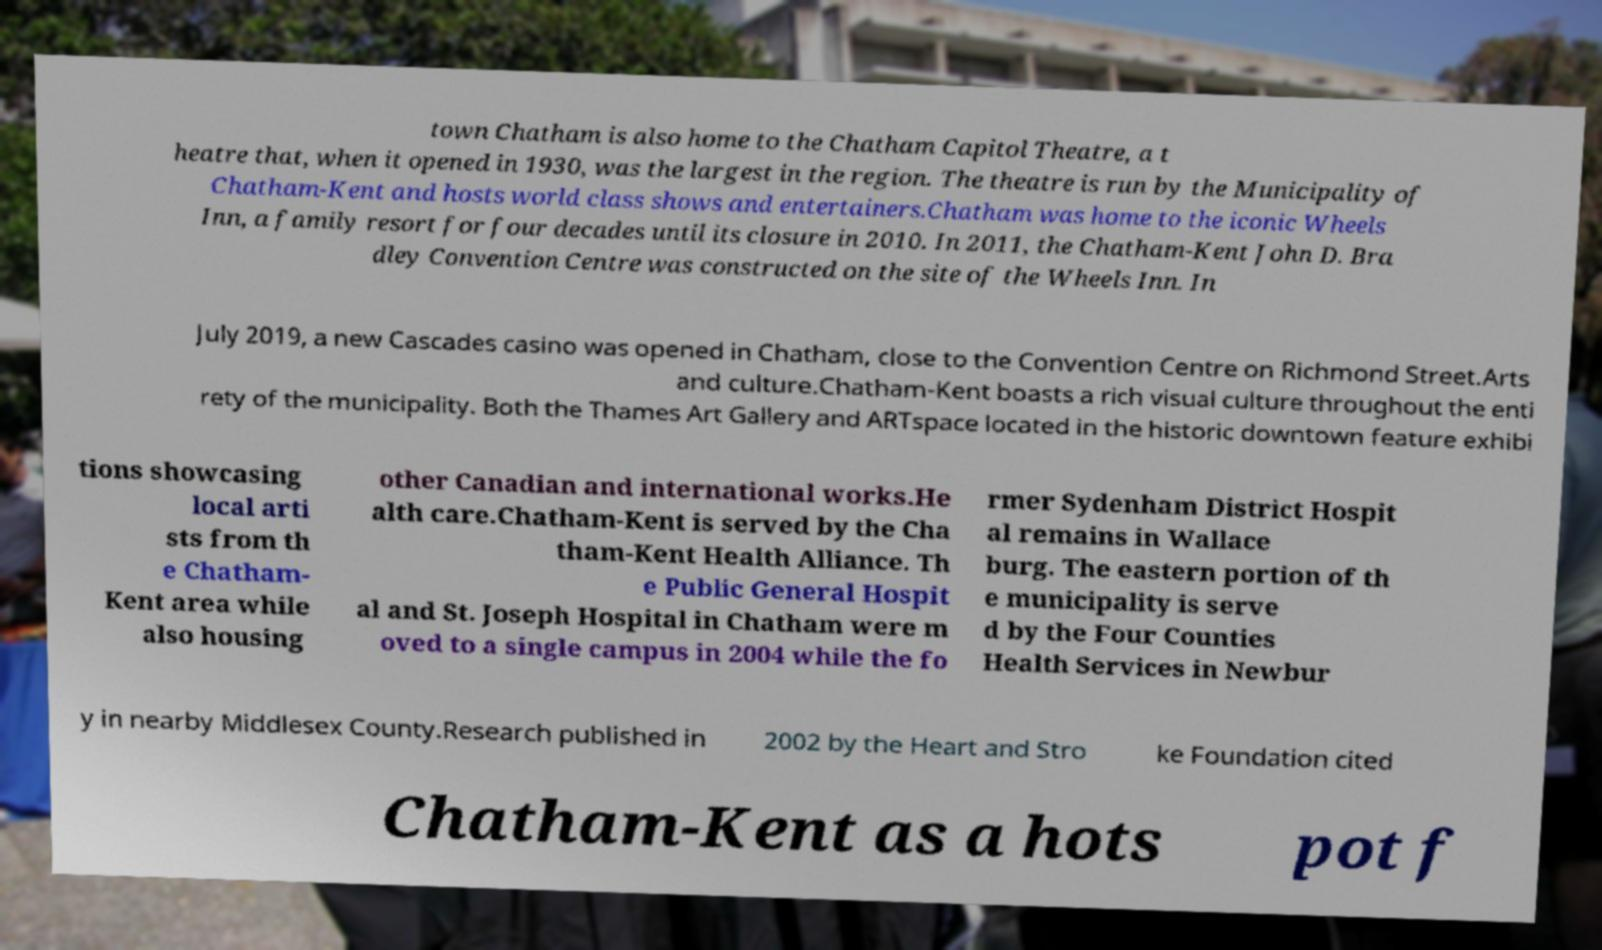What messages or text are displayed in this image? I need them in a readable, typed format. town Chatham is also home to the Chatham Capitol Theatre, a t heatre that, when it opened in 1930, was the largest in the region. The theatre is run by the Municipality of Chatham-Kent and hosts world class shows and entertainers.Chatham was home to the iconic Wheels Inn, a family resort for four decades until its closure in 2010. In 2011, the Chatham-Kent John D. Bra dley Convention Centre was constructed on the site of the Wheels Inn. In July 2019, a new Cascades casino was opened in Chatham, close to the Convention Centre on Richmond Street.Arts and culture.Chatham-Kent boasts a rich visual culture throughout the enti rety of the municipality. Both the Thames Art Gallery and ARTspace located in the historic downtown feature exhibi tions showcasing local arti sts from th e Chatham- Kent area while also housing other Canadian and international works.He alth care.Chatham-Kent is served by the Cha tham-Kent Health Alliance. Th e Public General Hospit al and St. Joseph Hospital in Chatham were m oved to a single campus in 2004 while the fo rmer Sydenham District Hospit al remains in Wallace burg. The eastern portion of th e municipality is serve d by the Four Counties Health Services in Newbur y in nearby Middlesex County.Research published in 2002 by the Heart and Stro ke Foundation cited Chatham-Kent as a hots pot f 